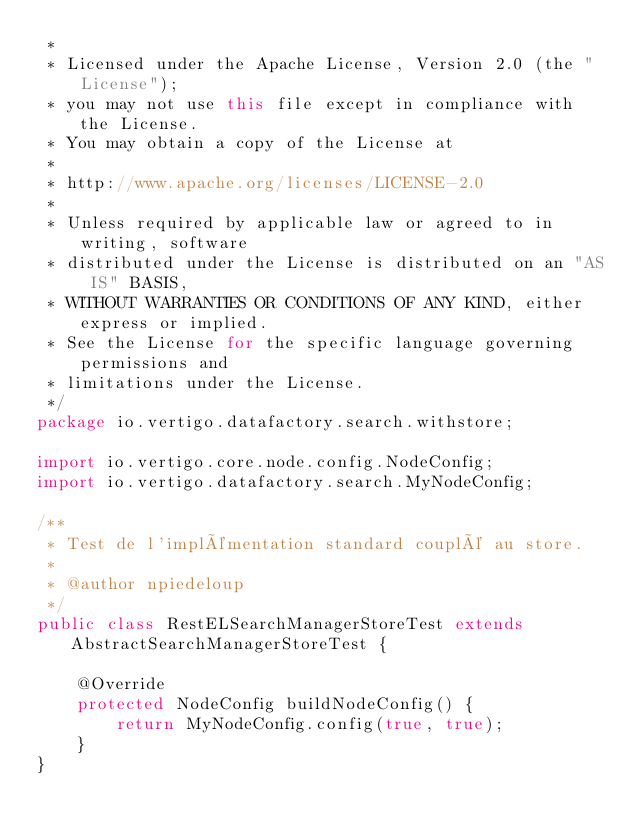Convert code to text. <code><loc_0><loc_0><loc_500><loc_500><_Java_> *
 * Licensed under the Apache License, Version 2.0 (the "License");
 * you may not use this file except in compliance with the License.
 * You may obtain a copy of the License at
 *
 * http://www.apache.org/licenses/LICENSE-2.0
 *
 * Unless required by applicable law or agreed to in writing, software
 * distributed under the License is distributed on an "AS IS" BASIS,
 * WITHOUT WARRANTIES OR CONDITIONS OF ANY KIND, either express or implied.
 * See the License for the specific language governing permissions and
 * limitations under the License.
 */
package io.vertigo.datafactory.search.withstore;

import io.vertigo.core.node.config.NodeConfig;
import io.vertigo.datafactory.search.MyNodeConfig;

/**
 * Test de l'implémentation standard couplé au store.
 *
 * @author npiedeloup
 */
public class RestELSearchManagerStoreTest extends AbstractSearchManagerStoreTest {

	@Override
	protected NodeConfig buildNodeConfig() {
		return MyNodeConfig.config(true, true);
	}
}
</code> 